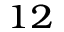Convert formula to latex. <formula><loc_0><loc_0><loc_500><loc_500>^ { 1 2 }</formula> 